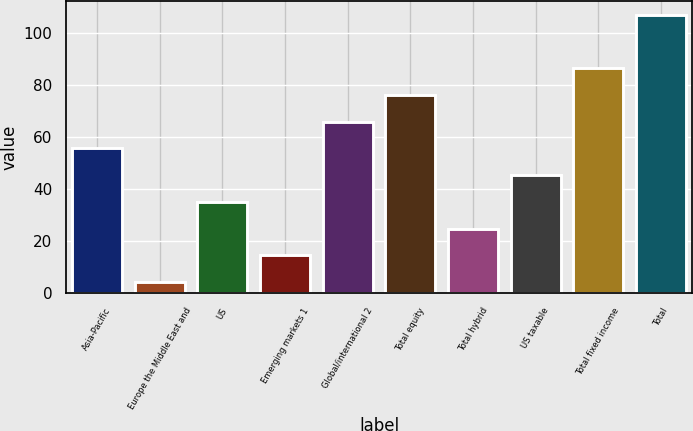<chart> <loc_0><loc_0><loc_500><loc_500><bar_chart><fcel>Asia-Pacific<fcel>Europe the Middle East and<fcel>US<fcel>Emerging markets 1<fcel>Global/international 2<fcel>Total equity<fcel>Total hybrid<fcel>US taxable<fcel>Total fixed income<fcel>Total<nl><fcel>55.7<fcel>4.2<fcel>35.1<fcel>14.5<fcel>66<fcel>76.3<fcel>24.8<fcel>45.4<fcel>86.6<fcel>107.2<nl></chart> 